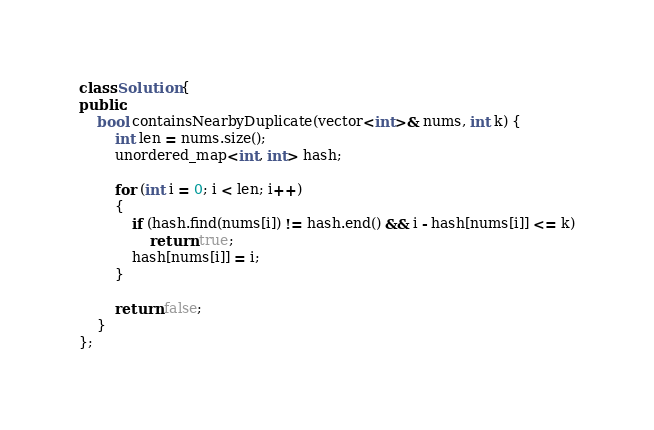<code> <loc_0><loc_0><loc_500><loc_500><_C++_>class Solution {
public:
    bool containsNearbyDuplicate(vector<int>& nums, int k) {
        int len = nums.size();
        unordered_map<int, int> hash;
        
        for (int i = 0; i < len; i++)
        {
            if (hash.find(nums[i]) != hash.end() && i - hash[nums[i]] <= k)
                return true;
            hash[nums[i]] = i;
        }
    
        return false;
    }
};</code> 